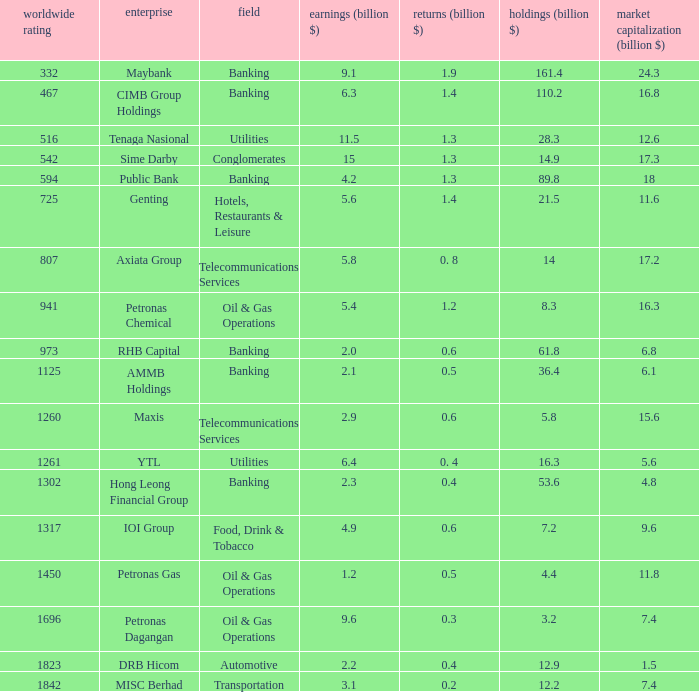Name the profits for market value of 11.8 0.5. 